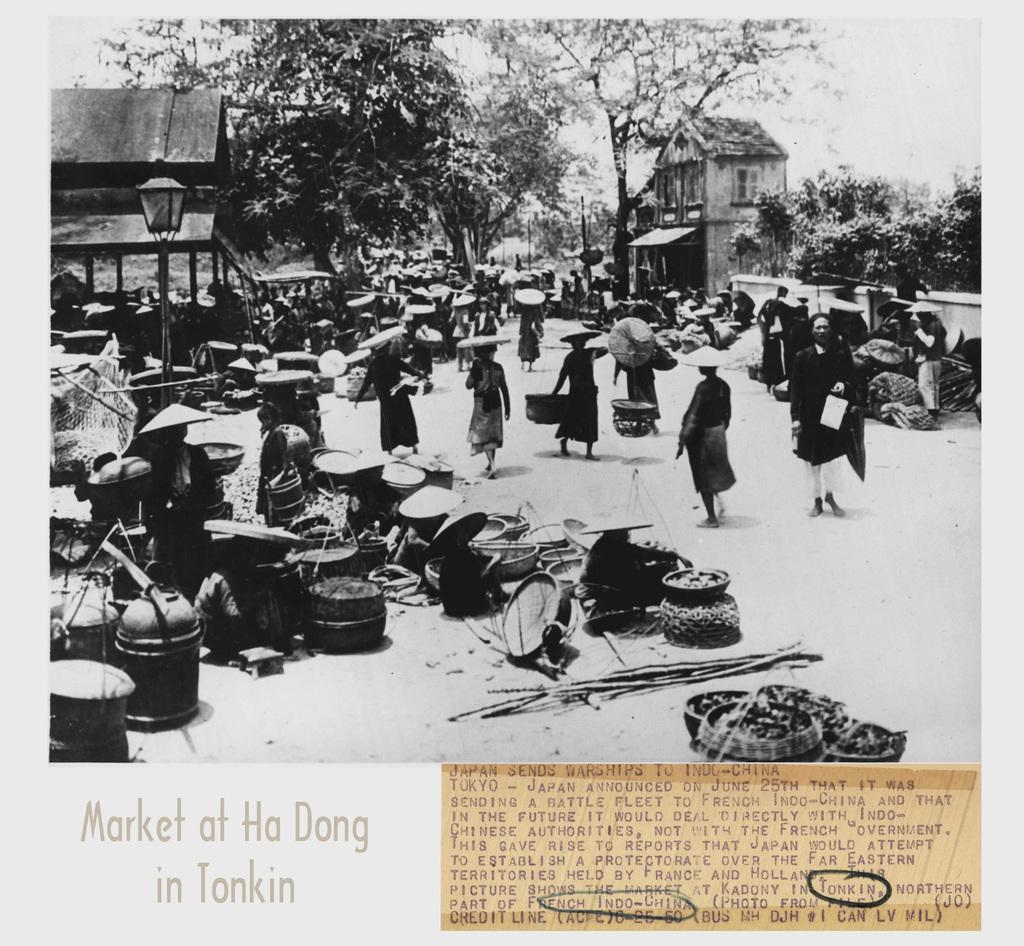Where is this picture taken?
Ensure brevity in your answer.  Market at ha dong in tonkin. What is the first word that is circled?
Your answer should be very brief. Tonkin. 